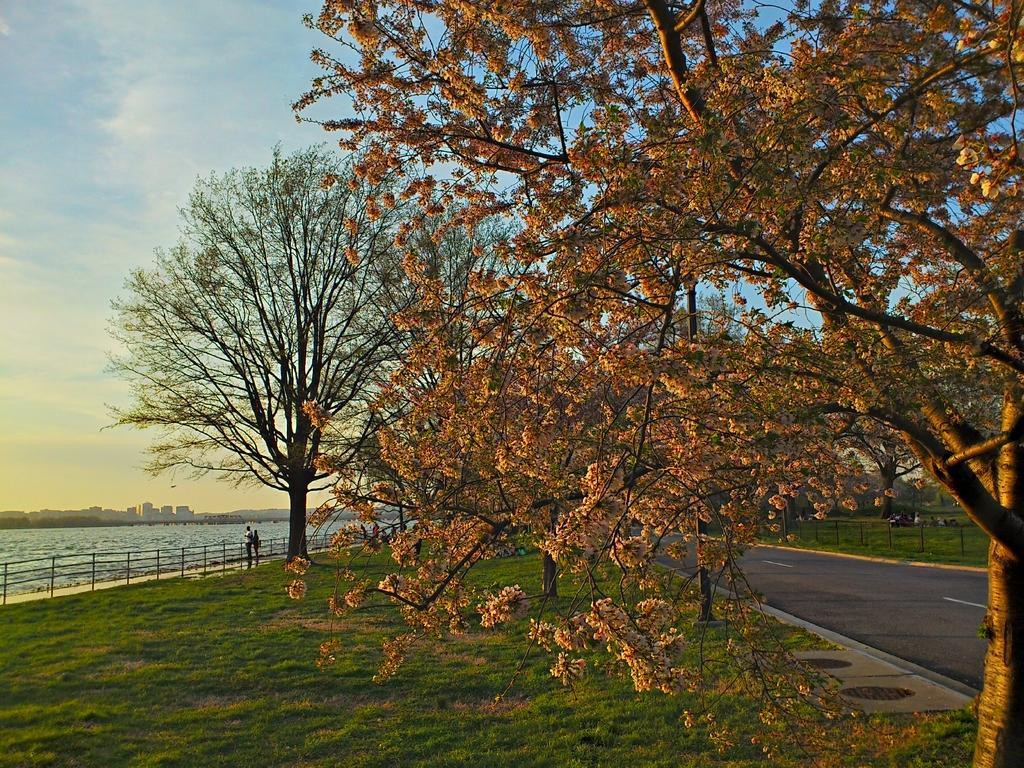What type of natural elements can be seen in the image? There are trees and water visible in the image. What type of man-made structures are present in the image? There are buildings and fencing visible in the image. What is visible in the sky in the image? The sky is visible in the image. Are there any living beings present in the image? Yes, there are people standing in the image. What type of amusement can be seen in the image? There is no amusement present in the image; it features trees, water, fencing, buildings, the sky, and people. Can you describe the roll of the insect in the image? There is no insect present in the image, so it is not possible to describe its roll. 